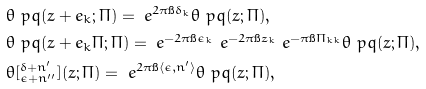Convert formula to latex. <formula><loc_0><loc_0><loc_500><loc_500>& \theta \ p q ( z + e _ { k } ; \Pi ) = \ e ^ { 2 \pi \i \delta _ { k } } \theta \ p q ( z ; \Pi ) , \\ & \theta \ p q ( z + e _ { k } \Pi ; \Pi ) = \ e ^ { - 2 \pi \i \epsilon _ { k } } \ e ^ { - 2 \pi \i z _ { k } } \ e ^ { - \pi \i \Pi _ { k k } } \theta \ p q ( z ; \Pi ) , \\ & \theta [ ^ { \delta + n ^ { \prime } } _ { \epsilon + n ^ { \prime \prime } } ] ( z ; \Pi ) = \ e ^ { 2 \pi \i \langle \epsilon , n ^ { \prime } \rangle } \theta \ p q ( z ; \Pi ) ,</formula> 